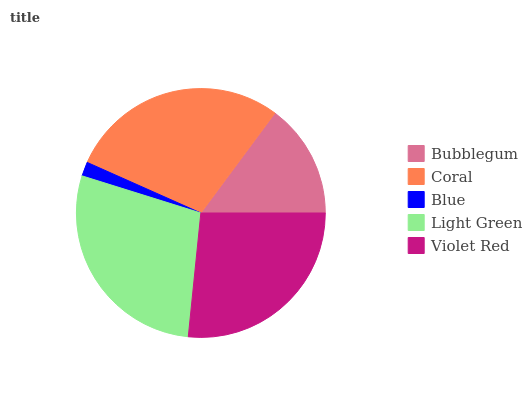Is Blue the minimum?
Answer yes or no. Yes. Is Coral the maximum?
Answer yes or no. Yes. Is Coral the minimum?
Answer yes or no. No. Is Blue the maximum?
Answer yes or no. No. Is Coral greater than Blue?
Answer yes or no. Yes. Is Blue less than Coral?
Answer yes or no. Yes. Is Blue greater than Coral?
Answer yes or no. No. Is Coral less than Blue?
Answer yes or no. No. Is Violet Red the high median?
Answer yes or no. Yes. Is Violet Red the low median?
Answer yes or no. Yes. Is Bubblegum the high median?
Answer yes or no. No. Is Coral the low median?
Answer yes or no. No. 